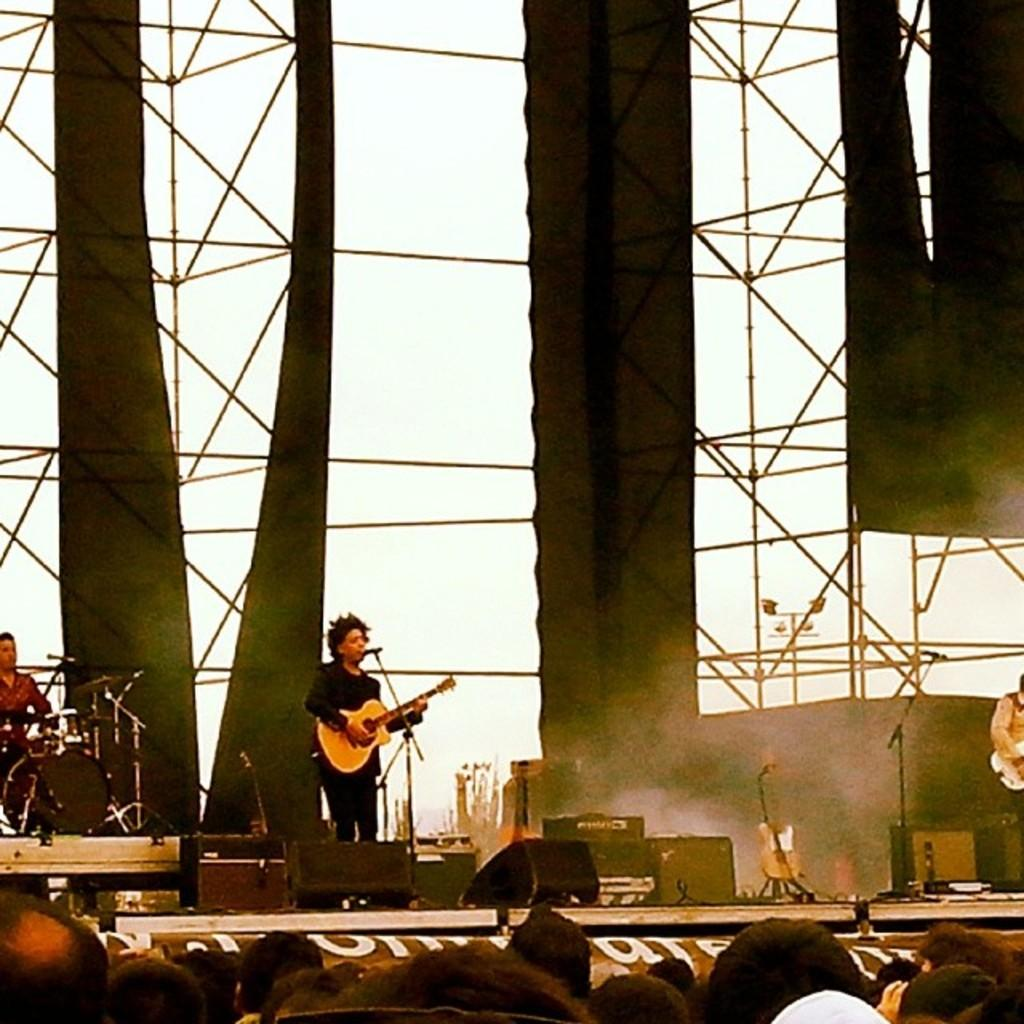Who is present in the image? There is a person in the image. What is the person holding in the image? The person is holding a guitar. What other object can be seen in the image? There is a microphone in the image. What is the person standing on in the image? There is a stand in the image. Where is the person playing the musical instrument? The person is playing a musical instrument on a stage in the background. What type of cushion is placed on the home in the image? There is no cushion or home present in the image. 